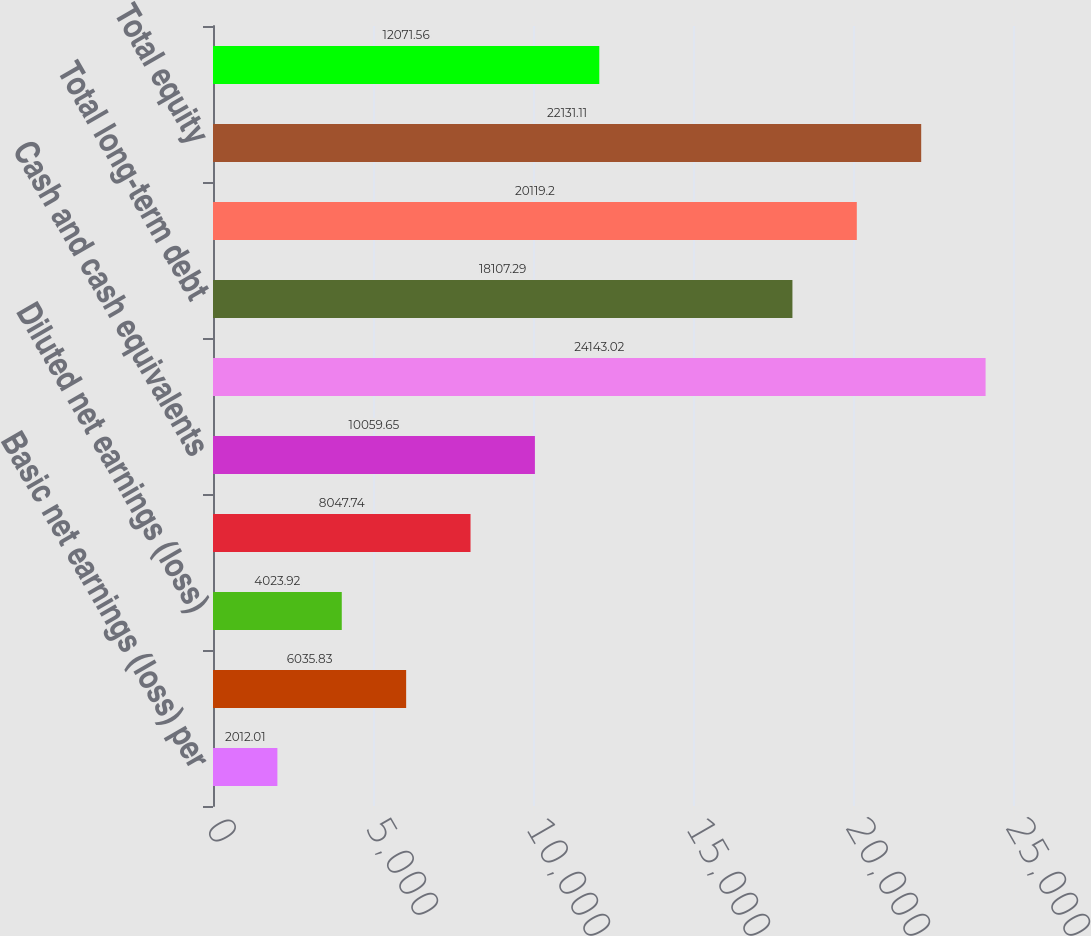Convert chart to OTSL. <chart><loc_0><loc_0><loc_500><loc_500><bar_chart><fcel>Basic net earnings (loss) per<fcel>Basic weighted average number<fcel>Diluted net earnings (loss)<fcel>Diluted weighted average<fcel>Cash and cash equivalents<fcel>Total assets<fcel>Total long-term debt<fcel>Total liabilities<fcel>Total equity<fcel>Depreciation depletion and<nl><fcel>2012.01<fcel>6035.83<fcel>4023.92<fcel>8047.74<fcel>10059.6<fcel>24143<fcel>18107.3<fcel>20119.2<fcel>22131.1<fcel>12071.6<nl></chart> 